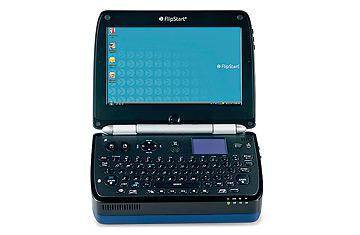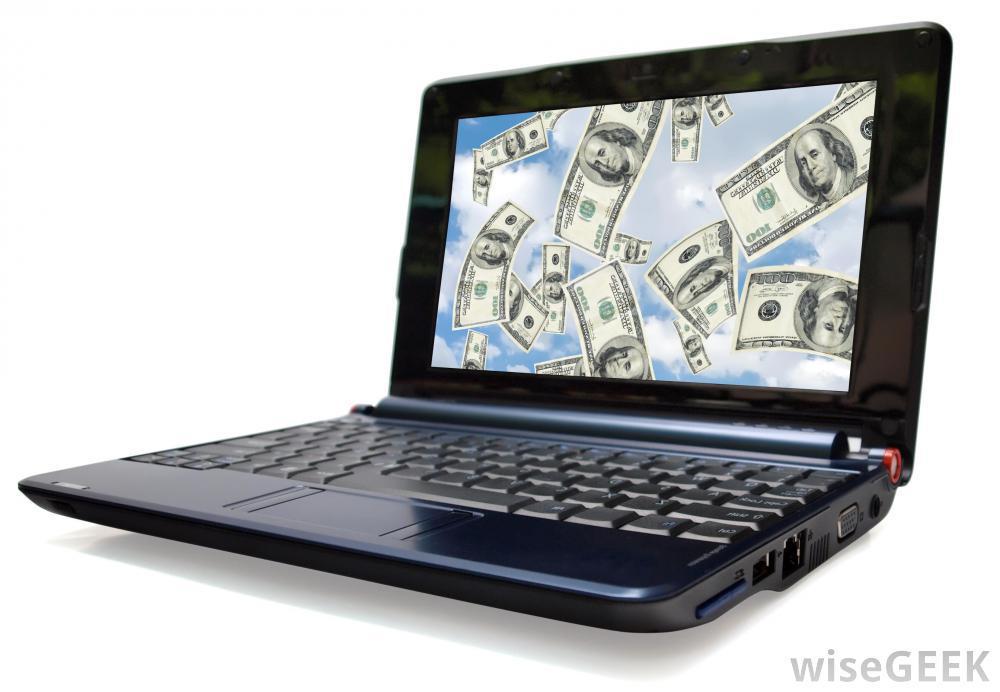The first image is the image on the left, the second image is the image on the right. Considering the images on both sides, is "The laptop on the left image has a silver body around the keyboard." valid? Answer yes or no. No. 